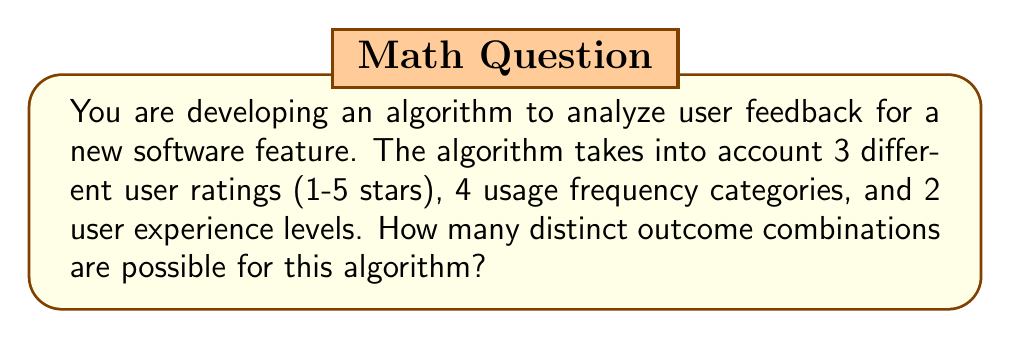Help me with this question. Let's break this down step-by-step:

1) We have three independent variables:
   - User ratings: 5 possibilities (1-5 stars)
   - Usage frequency categories: 4 possibilities
   - User experience levels: 2 possibilities

2) For each variable, we need to consider all possible outcomes. In combinatorics, when we have independent events and we want to know the total number of possible outcomes, we use the multiplication principle.

3) The multiplication principle states that if we have $m$ ways of doing something, $n$ ways of doing another thing, and $p$ ways of doing a third thing, then there are $m \times n \times p$ ways to do all three things.

4) In this case, we have:
   - 5 possible outcomes for user ratings
   - 4 possible outcomes for usage frequency
   - 2 possible outcomes for user experience level

5) Applying the multiplication principle:

   $$ \text{Total outcomes} = 5 \times 4 \times 2 $$

6) Calculating:

   $$ \text{Total outcomes} = 40 $$

Therefore, there are 40 distinct outcome combinations possible for this algorithm.
Answer: 40 